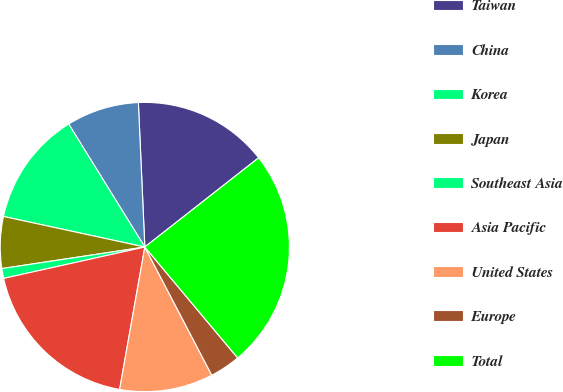<chart> <loc_0><loc_0><loc_500><loc_500><pie_chart><fcel>Taiwan<fcel>China<fcel>Korea<fcel>Japan<fcel>Southeast Asia<fcel>Asia Pacific<fcel>United States<fcel>Europe<fcel>Total<nl><fcel>15.13%<fcel>8.11%<fcel>12.79%<fcel>5.77%<fcel>1.1%<fcel>18.73%<fcel>10.45%<fcel>3.43%<fcel>24.49%<nl></chart> 